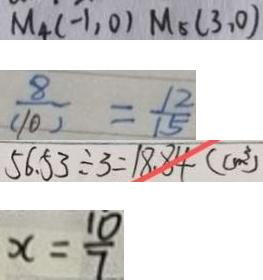<formula> <loc_0><loc_0><loc_500><loc_500>M _ { 4 } ( - 1 , 0 ) M _ { 5 } ( 3 , 0 ) 
 \frac { 8 } { ( 1 0 ) } = \frac { 1 2 } { 1 5 } 
 5 6 . 5 3 \div 3 = 1 8 . 8 4 ( c m ^ { 3 } ) 
 x = \frac { 1 0 } { 7 }</formula> 